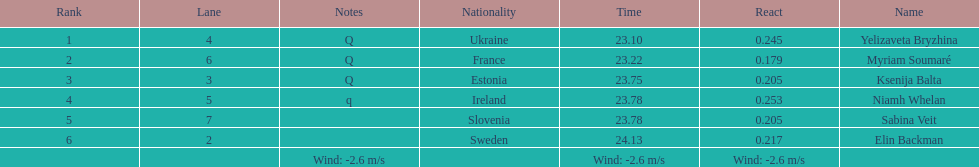The first person to finish in heat 1? Yelizaveta Bryzhina. 